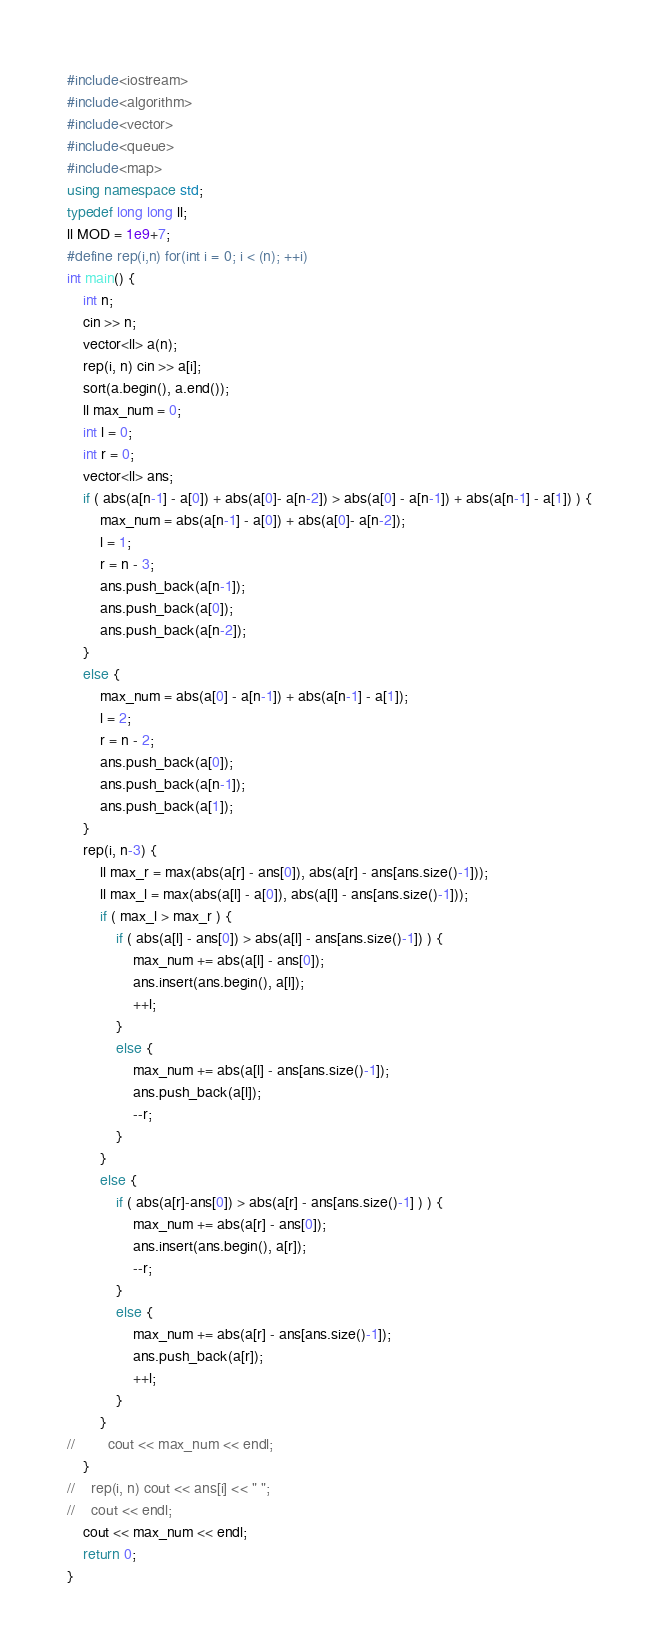Convert code to text. <code><loc_0><loc_0><loc_500><loc_500><_C++_>#include<iostream>
#include<algorithm>
#include<vector>
#include<queue>
#include<map>
using namespace std;
typedef long long ll;
ll MOD = 1e9+7;
#define rep(i,n) for(int i = 0; i < (n); ++i)
int main() {
    int n;
    cin >> n;
    vector<ll> a(n);
    rep(i, n) cin >> a[i];
    sort(a.begin(), a.end());
    ll max_num = 0;
    int l = 0;
    int r = 0;
    vector<ll> ans;
    if ( abs(a[n-1] - a[0]) + abs(a[0]- a[n-2]) > abs(a[0] - a[n-1]) + abs(a[n-1] - a[1]) ) {
        max_num = abs(a[n-1] - a[0]) + abs(a[0]- a[n-2]);
        l = 1;
        r = n - 3;
        ans.push_back(a[n-1]);
        ans.push_back(a[0]);
        ans.push_back(a[n-2]);
    }
    else {
        max_num = abs(a[0] - a[n-1]) + abs(a[n-1] - a[1]);
        l = 2;
        r = n - 2;
        ans.push_back(a[0]);
        ans.push_back(a[n-1]);
        ans.push_back(a[1]);
    }
    rep(i, n-3) {
        ll max_r = max(abs(a[r] - ans[0]), abs(a[r] - ans[ans.size()-1]));
        ll max_l = max(abs(a[l] - a[0]), abs(a[l] - ans[ans.size()-1]));
        if ( max_l > max_r ) {
            if ( abs(a[l] - ans[0]) > abs(a[l] - ans[ans.size()-1]) ) {
                max_num += abs(a[l] - ans[0]);
                ans.insert(ans.begin(), a[l]);
                ++l;
            }
            else {
                max_num += abs(a[l] - ans[ans.size()-1]);
                ans.push_back(a[l]);
                --r;
            }
        }
        else {
            if ( abs(a[r]-ans[0]) > abs(a[r] - ans[ans.size()-1] ) ) {
                max_num += abs(a[r] - ans[0]);
                ans.insert(ans.begin(), a[r]);
                --r;
            }
            else {
                max_num += abs(a[r] - ans[ans.size()-1]);
                ans.push_back(a[r]);
                ++l;
            }
        }
//        cout << max_num << endl;
    }
//    rep(i, n) cout << ans[i] << " ";
//    cout << endl; 
    cout << max_num << endl;
    return 0;
}
</code> 